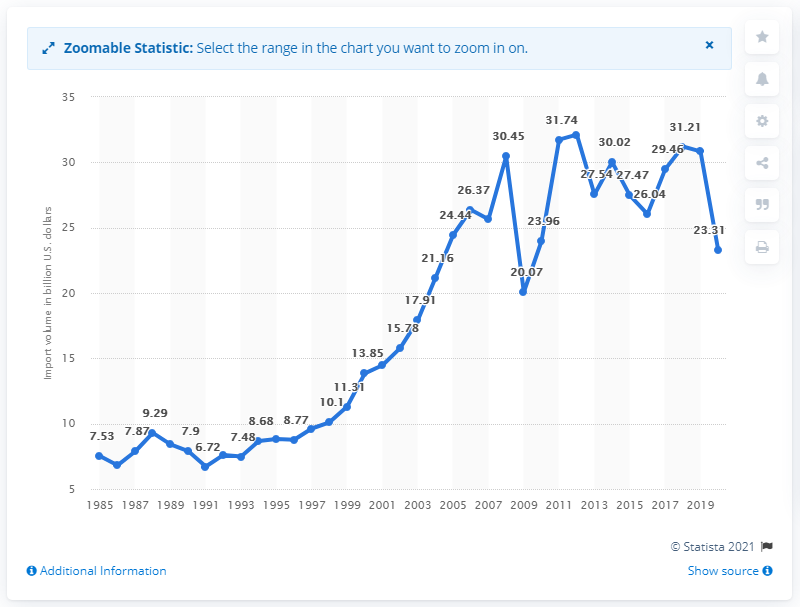Draw attention to some important aspects in this diagram. In 2020, the value of U.S. imports from Brazil was 23.31 billion dollars. 